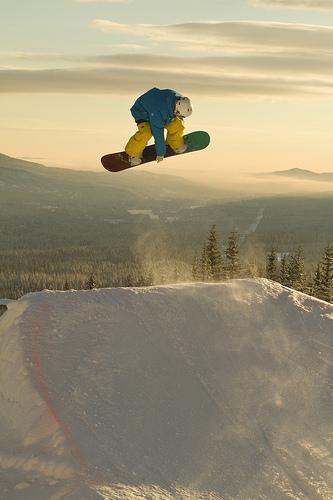How many people snowboarding?
Give a very brief answer. 1. 